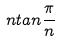Convert formula to latex. <formula><loc_0><loc_0><loc_500><loc_500>n t a n \frac { \pi } { n }</formula> 